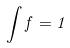Convert formula to latex. <formula><loc_0><loc_0><loc_500><loc_500>\int f = 1</formula> 